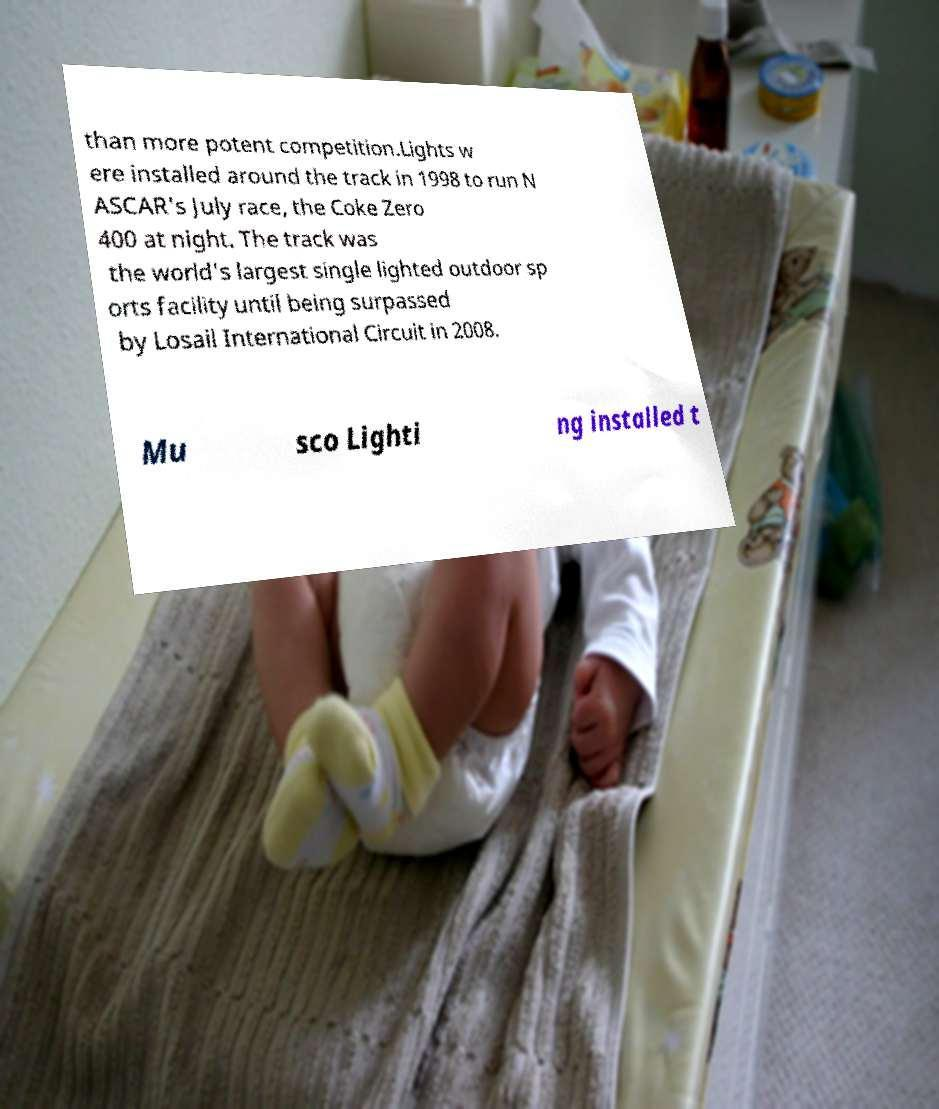Please identify and transcribe the text found in this image. than more potent competition.Lights w ere installed around the track in 1998 to run N ASCAR's July race, the Coke Zero 400 at night. The track was the world's largest single lighted outdoor sp orts facility until being surpassed by Losail International Circuit in 2008. Mu sco Lighti ng installed t 